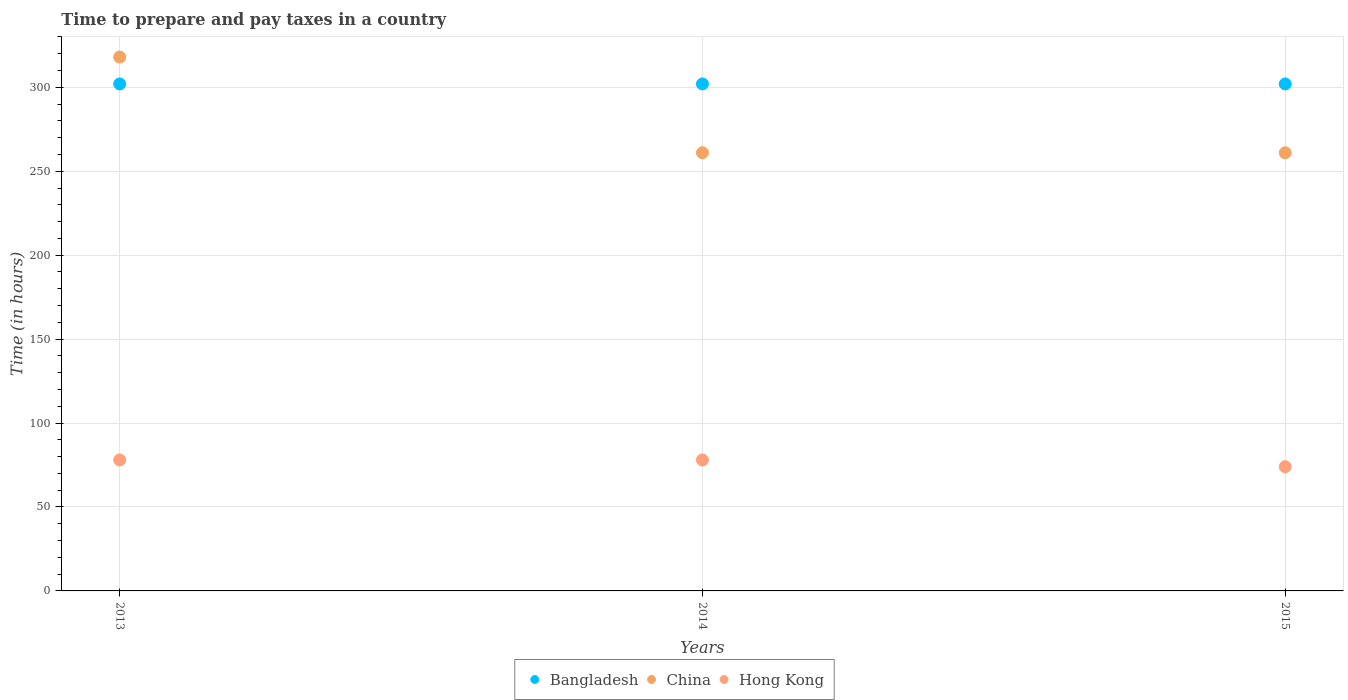Is the number of dotlines equal to the number of legend labels?
Your answer should be very brief. Yes. What is the number of hours required to prepare and pay taxes in Bangladesh in 2015?
Provide a succinct answer. 302. Across all years, what is the maximum number of hours required to prepare and pay taxes in Bangladesh?
Provide a succinct answer. 302. Across all years, what is the minimum number of hours required to prepare and pay taxes in Hong Kong?
Give a very brief answer. 74. In which year was the number of hours required to prepare and pay taxes in Hong Kong minimum?
Provide a succinct answer. 2015. What is the total number of hours required to prepare and pay taxes in China in the graph?
Your answer should be very brief. 840. What is the difference between the number of hours required to prepare and pay taxes in Bangladesh in 2015 and the number of hours required to prepare and pay taxes in Hong Kong in 2014?
Offer a very short reply. 224. What is the average number of hours required to prepare and pay taxes in Bangladesh per year?
Give a very brief answer. 302. In the year 2015, what is the difference between the number of hours required to prepare and pay taxes in Hong Kong and number of hours required to prepare and pay taxes in Bangladesh?
Keep it short and to the point. -228. In how many years, is the number of hours required to prepare and pay taxes in China greater than 20 hours?
Ensure brevity in your answer.  3. Is the number of hours required to prepare and pay taxes in Hong Kong in 2013 less than that in 2015?
Provide a succinct answer. No. What is the difference between the highest and the second highest number of hours required to prepare and pay taxes in China?
Your answer should be very brief. 57. What is the difference between the highest and the lowest number of hours required to prepare and pay taxes in China?
Ensure brevity in your answer.  57. Is the sum of the number of hours required to prepare and pay taxes in China in 2013 and 2014 greater than the maximum number of hours required to prepare and pay taxes in Bangladesh across all years?
Offer a very short reply. Yes. Does the number of hours required to prepare and pay taxes in China monotonically increase over the years?
Your response must be concise. No. Is the number of hours required to prepare and pay taxes in Hong Kong strictly less than the number of hours required to prepare and pay taxes in China over the years?
Provide a succinct answer. Yes. Does the graph contain any zero values?
Offer a terse response. No. Does the graph contain grids?
Give a very brief answer. Yes. How many legend labels are there?
Offer a very short reply. 3. How are the legend labels stacked?
Ensure brevity in your answer.  Horizontal. What is the title of the graph?
Your response must be concise. Time to prepare and pay taxes in a country. Does "Benin" appear as one of the legend labels in the graph?
Provide a short and direct response. No. What is the label or title of the X-axis?
Give a very brief answer. Years. What is the label or title of the Y-axis?
Offer a terse response. Time (in hours). What is the Time (in hours) in Bangladesh in 2013?
Offer a very short reply. 302. What is the Time (in hours) in China in 2013?
Keep it short and to the point. 318. What is the Time (in hours) of Bangladesh in 2014?
Offer a terse response. 302. What is the Time (in hours) in China in 2014?
Ensure brevity in your answer.  261. What is the Time (in hours) in Hong Kong in 2014?
Your response must be concise. 78. What is the Time (in hours) of Bangladesh in 2015?
Make the answer very short. 302. What is the Time (in hours) in China in 2015?
Your response must be concise. 261. What is the Time (in hours) of Hong Kong in 2015?
Make the answer very short. 74. Across all years, what is the maximum Time (in hours) of Bangladesh?
Your answer should be compact. 302. Across all years, what is the maximum Time (in hours) of China?
Provide a short and direct response. 318. Across all years, what is the maximum Time (in hours) in Hong Kong?
Offer a terse response. 78. Across all years, what is the minimum Time (in hours) in Bangladesh?
Provide a short and direct response. 302. Across all years, what is the minimum Time (in hours) of China?
Your answer should be compact. 261. Across all years, what is the minimum Time (in hours) in Hong Kong?
Ensure brevity in your answer.  74. What is the total Time (in hours) of Bangladesh in the graph?
Your answer should be very brief. 906. What is the total Time (in hours) of China in the graph?
Give a very brief answer. 840. What is the total Time (in hours) in Hong Kong in the graph?
Give a very brief answer. 230. What is the difference between the Time (in hours) of Bangladesh in 2013 and that in 2014?
Ensure brevity in your answer.  0. What is the difference between the Time (in hours) in China in 2013 and that in 2014?
Offer a very short reply. 57. What is the difference between the Time (in hours) in China in 2013 and that in 2015?
Your answer should be very brief. 57. What is the difference between the Time (in hours) of Bangladesh in 2014 and that in 2015?
Provide a short and direct response. 0. What is the difference between the Time (in hours) of China in 2014 and that in 2015?
Offer a terse response. 0. What is the difference between the Time (in hours) of Hong Kong in 2014 and that in 2015?
Make the answer very short. 4. What is the difference between the Time (in hours) of Bangladesh in 2013 and the Time (in hours) of Hong Kong in 2014?
Offer a terse response. 224. What is the difference between the Time (in hours) of China in 2013 and the Time (in hours) of Hong Kong in 2014?
Make the answer very short. 240. What is the difference between the Time (in hours) of Bangladesh in 2013 and the Time (in hours) of Hong Kong in 2015?
Offer a very short reply. 228. What is the difference between the Time (in hours) in China in 2013 and the Time (in hours) in Hong Kong in 2015?
Your answer should be very brief. 244. What is the difference between the Time (in hours) of Bangladesh in 2014 and the Time (in hours) of China in 2015?
Your answer should be very brief. 41. What is the difference between the Time (in hours) of Bangladesh in 2014 and the Time (in hours) of Hong Kong in 2015?
Your answer should be very brief. 228. What is the difference between the Time (in hours) in China in 2014 and the Time (in hours) in Hong Kong in 2015?
Provide a short and direct response. 187. What is the average Time (in hours) of Bangladesh per year?
Give a very brief answer. 302. What is the average Time (in hours) of China per year?
Make the answer very short. 280. What is the average Time (in hours) of Hong Kong per year?
Give a very brief answer. 76.67. In the year 2013, what is the difference between the Time (in hours) in Bangladesh and Time (in hours) in Hong Kong?
Your answer should be compact. 224. In the year 2013, what is the difference between the Time (in hours) in China and Time (in hours) in Hong Kong?
Provide a succinct answer. 240. In the year 2014, what is the difference between the Time (in hours) in Bangladesh and Time (in hours) in Hong Kong?
Offer a terse response. 224. In the year 2014, what is the difference between the Time (in hours) of China and Time (in hours) of Hong Kong?
Make the answer very short. 183. In the year 2015, what is the difference between the Time (in hours) in Bangladesh and Time (in hours) in China?
Your response must be concise. 41. In the year 2015, what is the difference between the Time (in hours) in Bangladesh and Time (in hours) in Hong Kong?
Offer a terse response. 228. In the year 2015, what is the difference between the Time (in hours) in China and Time (in hours) in Hong Kong?
Offer a very short reply. 187. What is the ratio of the Time (in hours) in Bangladesh in 2013 to that in 2014?
Provide a succinct answer. 1. What is the ratio of the Time (in hours) of China in 2013 to that in 2014?
Ensure brevity in your answer.  1.22. What is the ratio of the Time (in hours) of Hong Kong in 2013 to that in 2014?
Offer a terse response. 1. What is the ratio of the Time (in hours) in China in 2013 to that in 2015?
Give a very brief answer. 1.22. What is the ratio of the Time (in hours) of Hong Kong in 2013 to that in 2015?
Make the answer very short. 1.05. What is the ratio of the Time (in hours) of China in 2014 to that in 2015?
Give a very brief answer. 1. What is the ratio of the Time (in hours) in Hong Kong in 2014 to that in 2015?
Make the answer very short. 1.05. What is the difference between the highest and the second highest Time (in hours) of Bangladesh?
Make the answer very short. 0. What is the difference between the highest and the second highest Time (in hours) of Hong Kong?
Ensure brevity in your answer.  0. What is the difference between the highest and the lowest Time (in hours) of China?
Your response must be concise. 57. What is the difference between the highest and the lowest Time (in hours) of Hong Kong?
Keep it short and to the point. 4. 